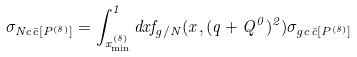Convert formula to latex. <formula><loc_0><loc_0><loc_500><loc_500>\sigma _ { N c \bar { c } [ P ^ { ( 8 ) } ] } = \int ^ { 1 } _ { x ^ { ( 8 ) } _ { \min } } d x f _ { g / N } ( x , ( q + Q ^ { 0 } ) ^ { 2 } ) \sigma _ { g c \bar { c } [ P ^ { ( 8 ) } ] }</formula> 